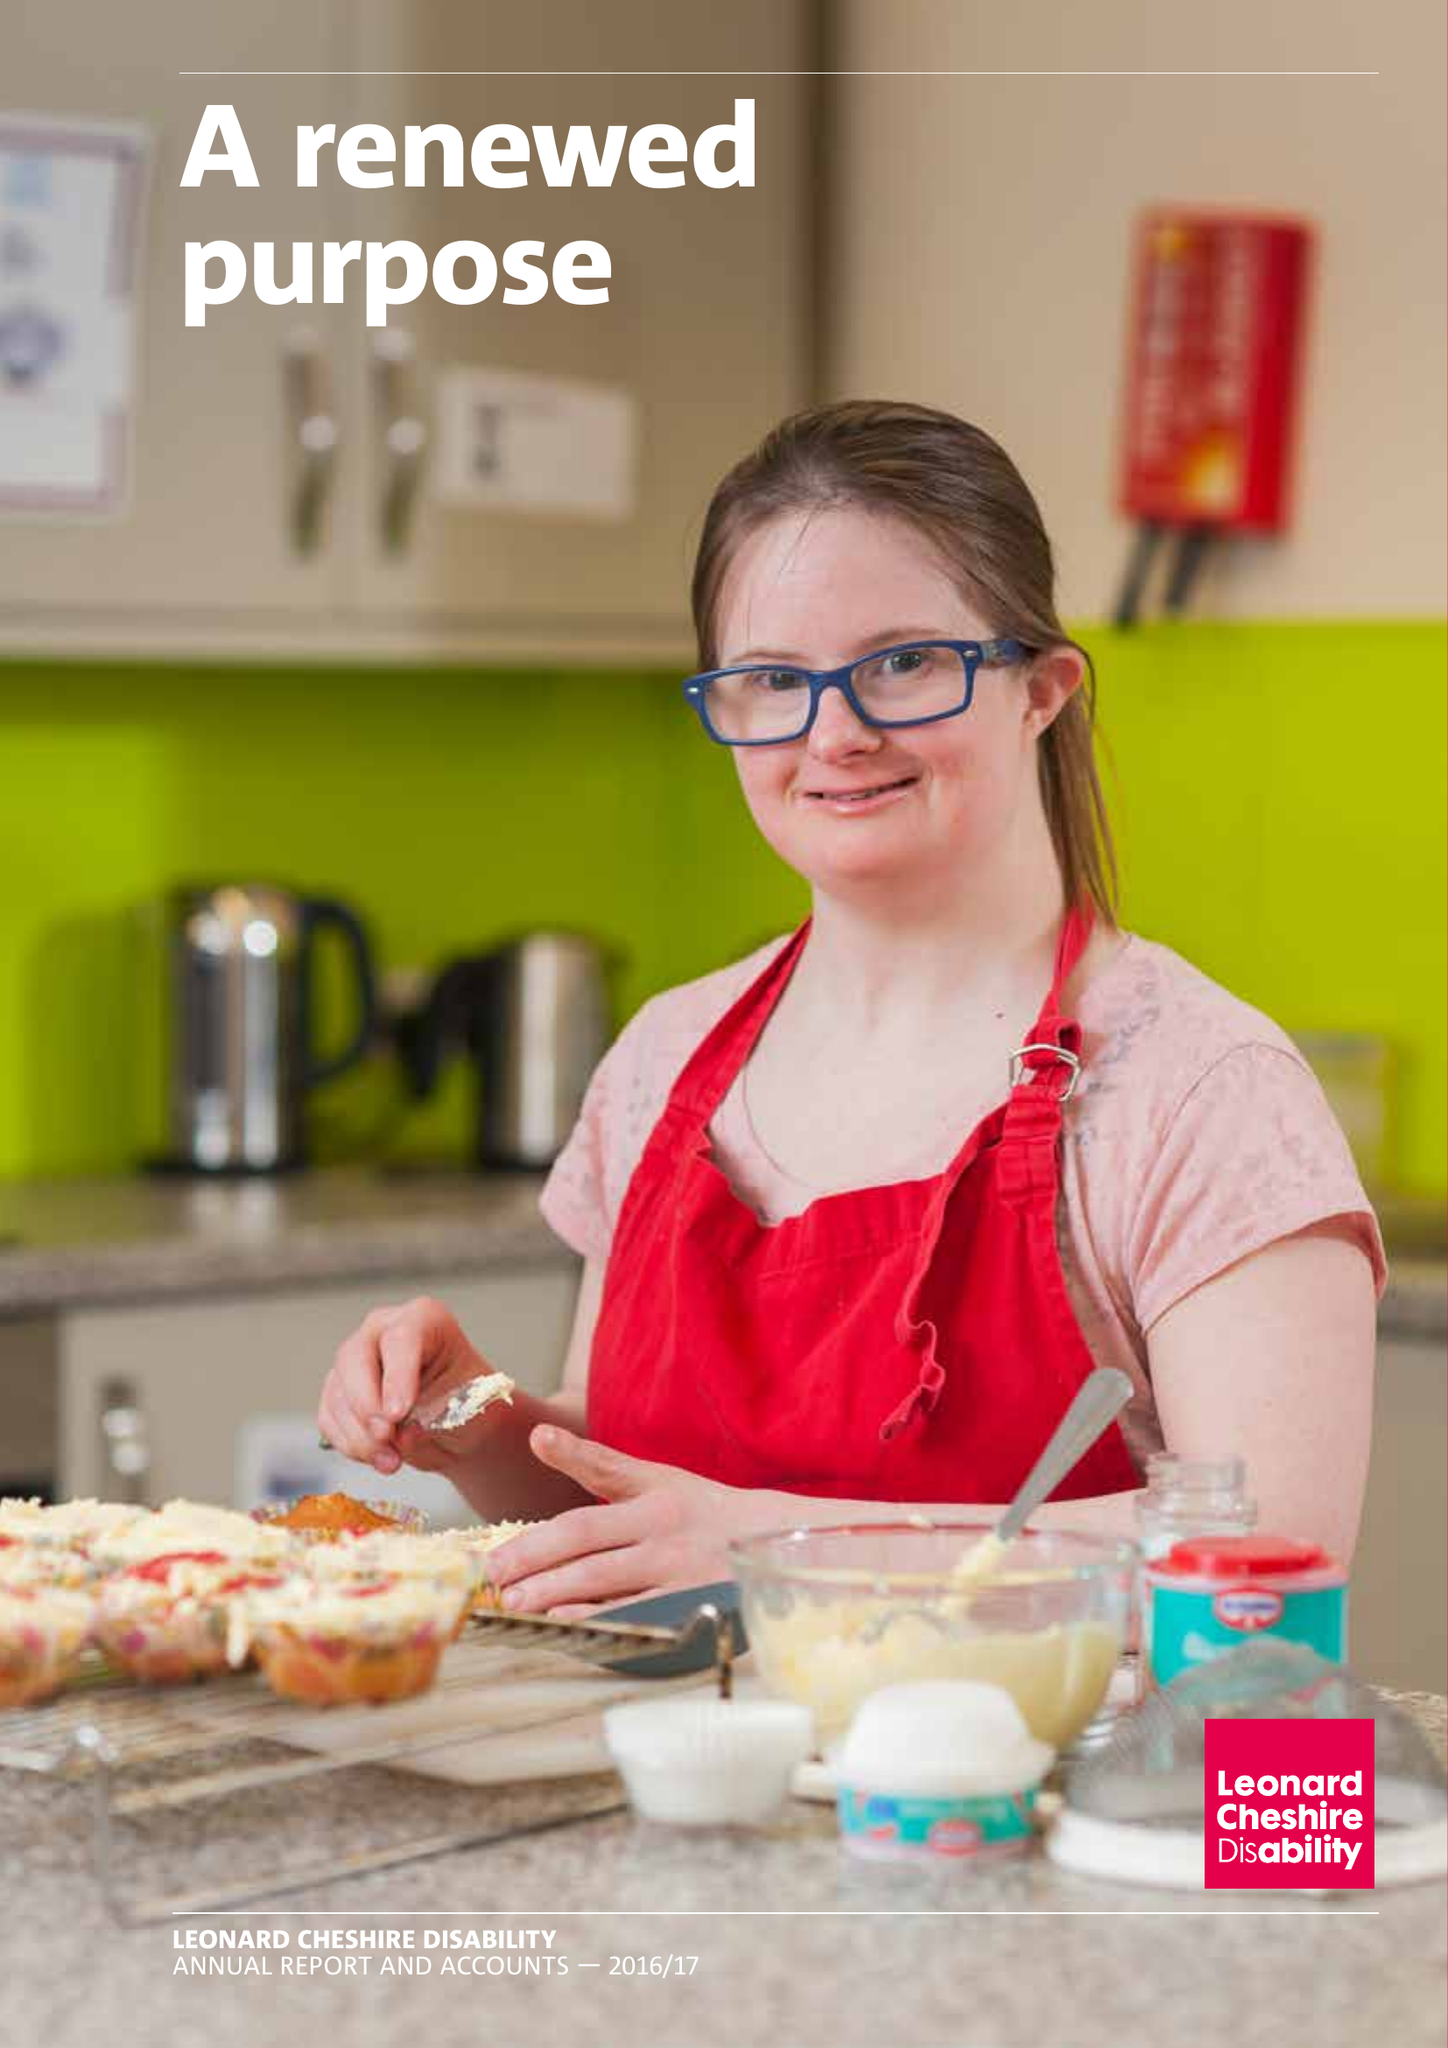What is the value for the charity_number?
Answer the question using a single word or phrase. 218186 